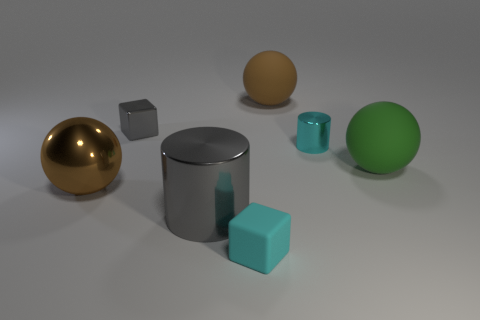What material is the cube that is the same color as the large shiny cylinder?
Your response must be concise. Metal. There is a small thing that is both behind the small cyan rubber object and right of the small metal block; what is its color?
Your answer should be very brief. Cyan. The cube to the left of the tiny block in front of the large brown metallic sphere is made of what material?
Make the answer very short. Metal. Is the gray metallic cube the same size as the cyan cylinder?
Your answer should be compact. Yes. How many tiny things are cylinders or green metal cubes?
Offer a very short reply. 1. There is a small rubber cube; how many things are on the right side of it?
Your answer should be compact. 3. Is the number of cylinders in front of the cyan cube greater than the number of small cyan blocks?
Provide a short and direct response. No. There is a brown thing that is the same material as the green sphere; what is its shape?
Your answer should be compact. Sphere. There is a tiny metallic object that is on the left side of the big shiny thing that is to the right of the metallic sphere; what is its color?
Provide a short and direct response. Gray. Do the cyan matte object and the tiny gray thing have the same shape?
Offer a very short reply. Yes. 